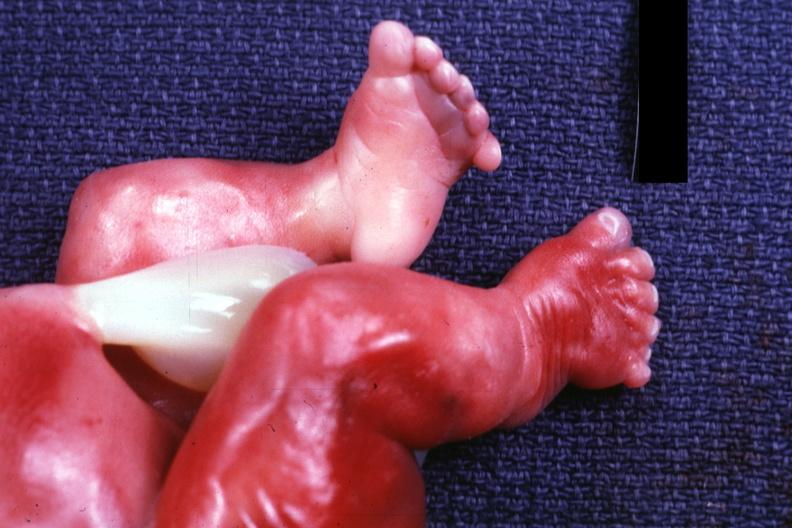s foot present?
Answer the question using a single word or phrase. Yes 